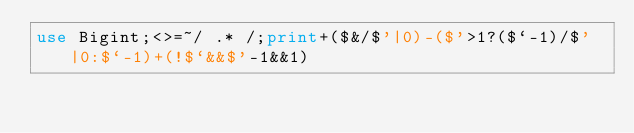Convert code to text. <code><loc_0><loc_0><loc_500><loc_500><_Perl_>use Bigint;<>=~/ .* /;print+($&/$'|0)-($'>1?($`-1)/$'|0:$`-1)+(!$`&&$'-1&&1)</code> 